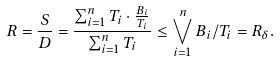<formula> <loc_0><loc_0><loc_500><loc_500>R = \frac { S } { D } = \frac { \sum _ { i = 1 } ^ { n } T _ { i } \cdot \frac { B _ { i } } { T _ { i } } } { \sum _ { i = 1 } ^ { n } T _ { i } } \leq \bigvee _ { i = 1 } ^ { n } B _ { i } / T _ { i } = R _ { \delta } .</formula> 